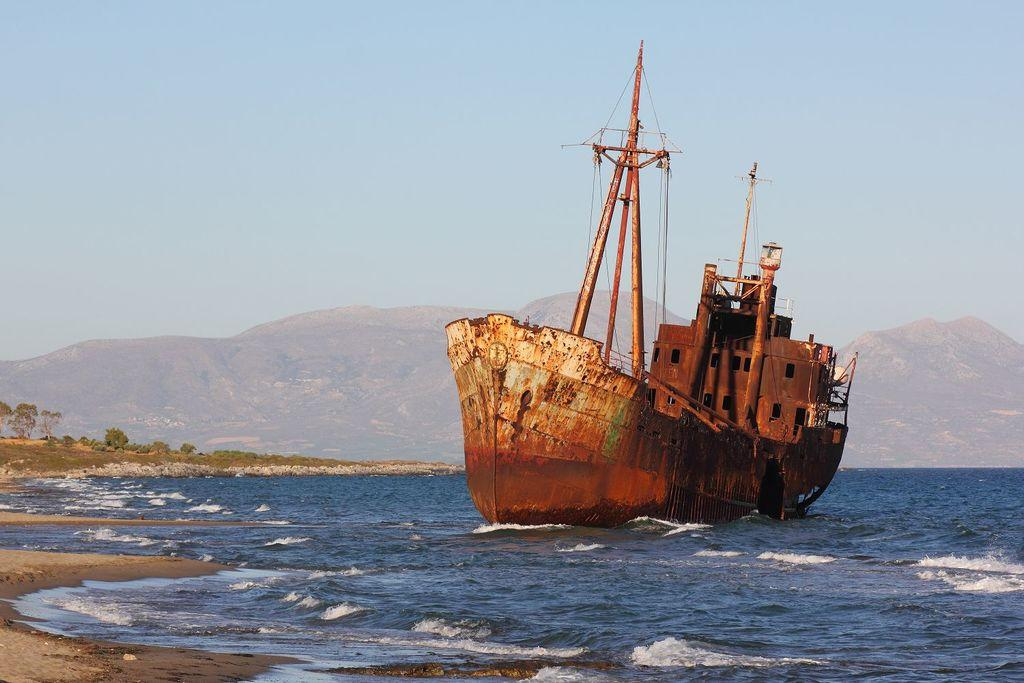What is the main subject of the image? There is a ship in the image. What is the ship doing in the image? The ship is sailing on the water. What can be seen in the background of the image? There are mountains visible in the background of the image. What type of juice is being served on the ship in the image? There is no juice visible in the image, as it only features a ship sailing on the water with mountains in the background. 